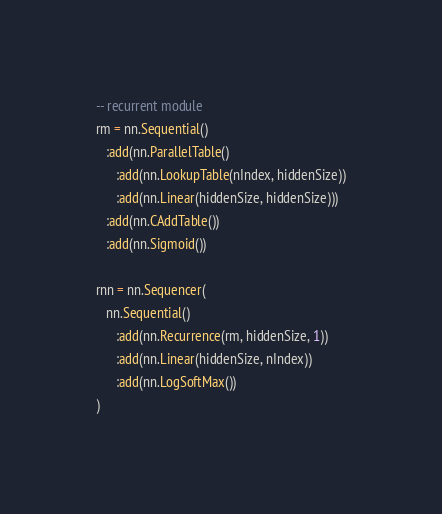<code> <loc_0><loc_0><loc_500><loc_500><_Lua_>-- recurrent module
rm = nn.Sequential()
   :add(nn.ParallelTable()
      :add(nn.LookupTable(nIndex, hiddenSize))
      :add(nn.Linear(hiddenSize, hiddenSize)))
   :add(nn.CAddTable())
   :add(nn.Sigmoid())

rnn = nn.Sequencer(
   nn.Sequential()
      :add(nn.Recurrence(rm, hiddenSize, 1))
      :add(nn.Linear(hiddenSize, nIndex))
      :add(nn.LogSoftMax())
)</code> 